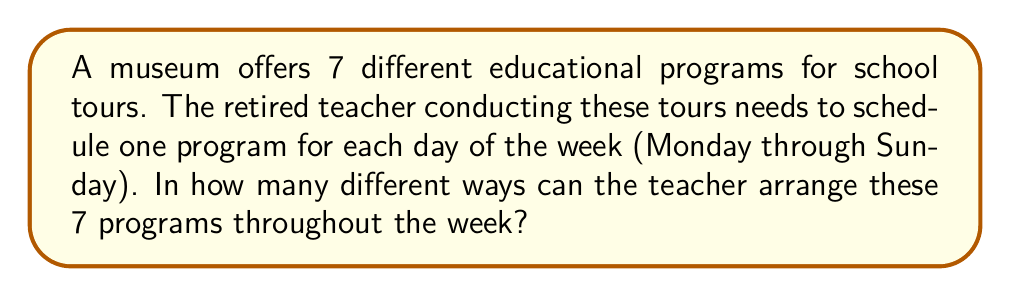Show me your answer to this math problem. Let's approach this step-by-step:

1) We have 7 different programs and 7 different days. Each program needs to be used exactly once, and each day needs to have exactly one program.

2) This scenario is a perfect example of a permutation problem. We are arranging all 7 programs in a specific order (the order of the days of the week).

3) The formula for permutations of n distinct objects is:

   $$P(n) = n!$$

   Where $n!$ represents the factorial of n.

4) In this case, $n = 7$ (as we have 7 programs to arrange).

5) Therefore, the number of ways to arrange the programs is:

   $$P(7) = 7!$$

6) Let's calculate 7!:
   
   $$7! = 7 \times 6 \times 5 \times 4 \times 3 \times 2 \times 1 = 5040$$

Thus, there are 5040 different ways to schedule the 7 educational programs throughout the week.
Answer: 5040 